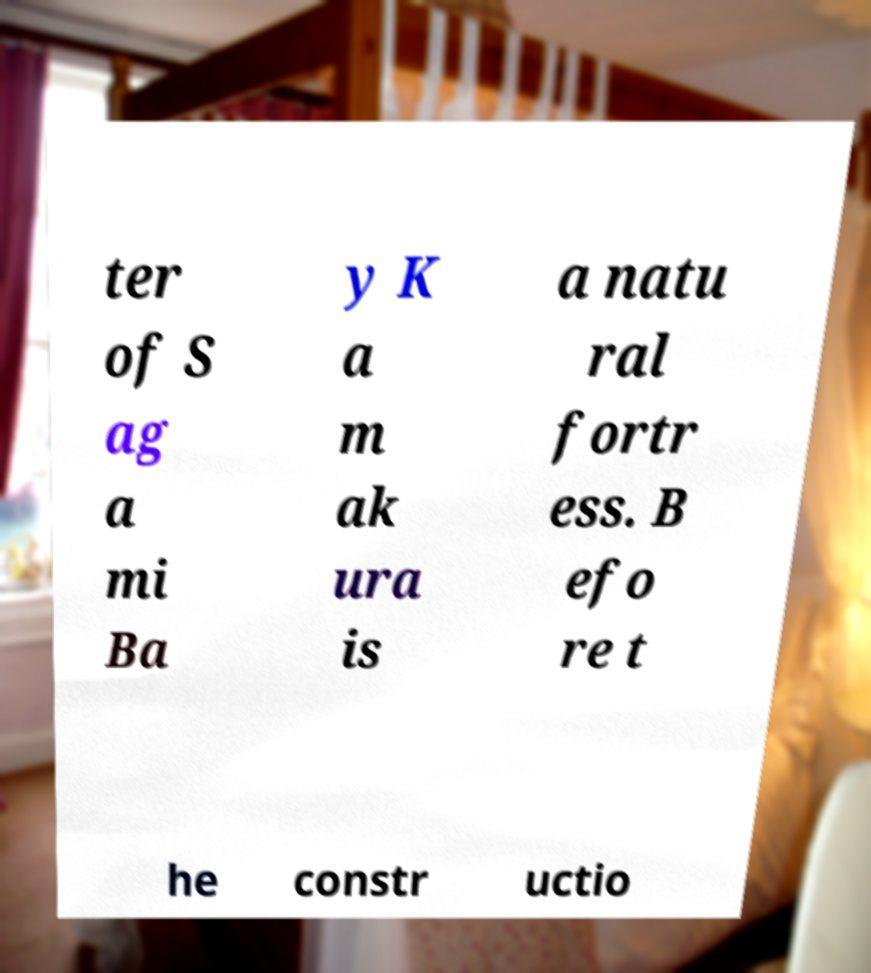Please identify and transcribe the text found in this image. ter of S ag a mi Ba y K a m ak ura is a natu ral fortr ess. B efo re t he constr uctio 